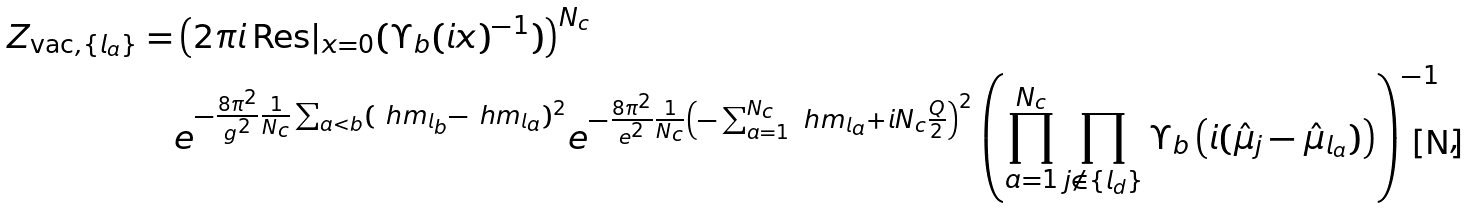<formula> <loc_0><loc_0><loc_500><loc_500>Z _ { \text {vac} , \{ l _ { a } \} } = & \left ( 2 \pi i \, \text {Res} | _ { x = 0 } ( \Upsilon _ { b } ( i x ) ^ { - 1 } ) \right ) ^ { N _ { c } } \\ & e ^ { - \frac { 8 \pi ^ { 2 } } { g ^ { 2 } } \frac { 1 } { N _ { c } } \sum _ { a < b } ( \ h m _ { l _ { b } } - \ h m _ { l _ { a } } ) ^ { 2 } } e ^ { - \frac { 8 \pi ^ { 2 } } { e ^ { 2 } } \frac { 1 } { N _ { c } } \left ( - \sum _ { a = 1 } ^ { N _ { c } } \ h m _ { l _ { a } } + i N _ { c } \frac { Q } { 2 } \right ) ^ { 2 } } \left ( \prod _ { a = 1 } ^ { N _ { c } } \prod _ { j \notin \{ l _ { d } \} } \Upsilon _ { b } \left ( i ( \hat { \mu } _ { j } - \hat { \mu } _ { l _ { a } } ) \right ) \right ) ^ { - 1 } \, ,</formula> 